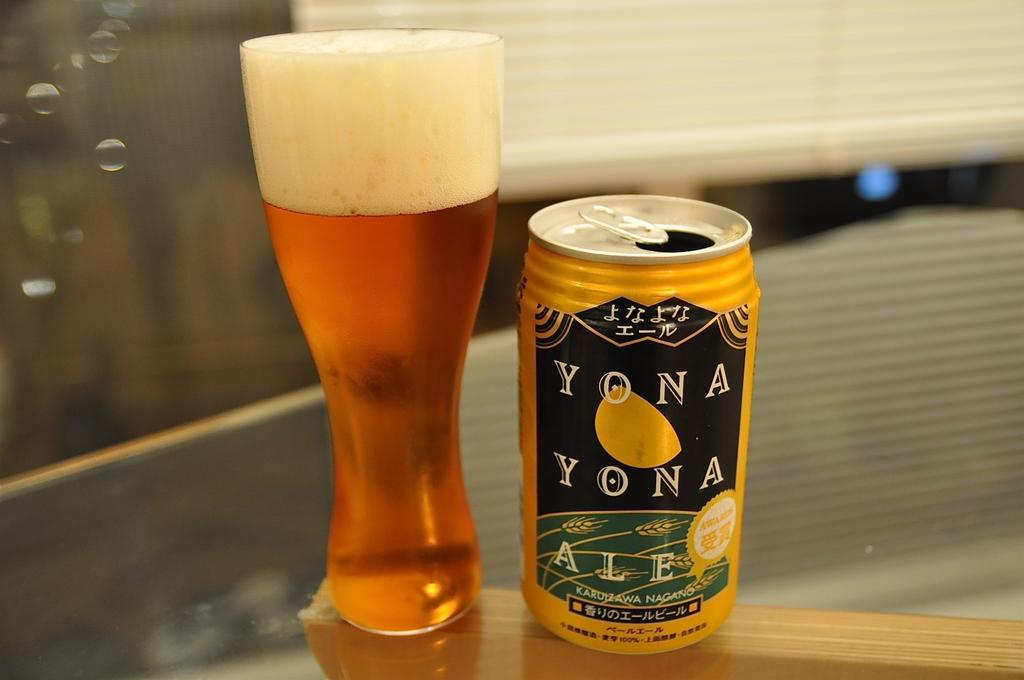<image>
Relay a brief, clear account of the picture shown. A full glass of Yona Yona ale next to its can. 